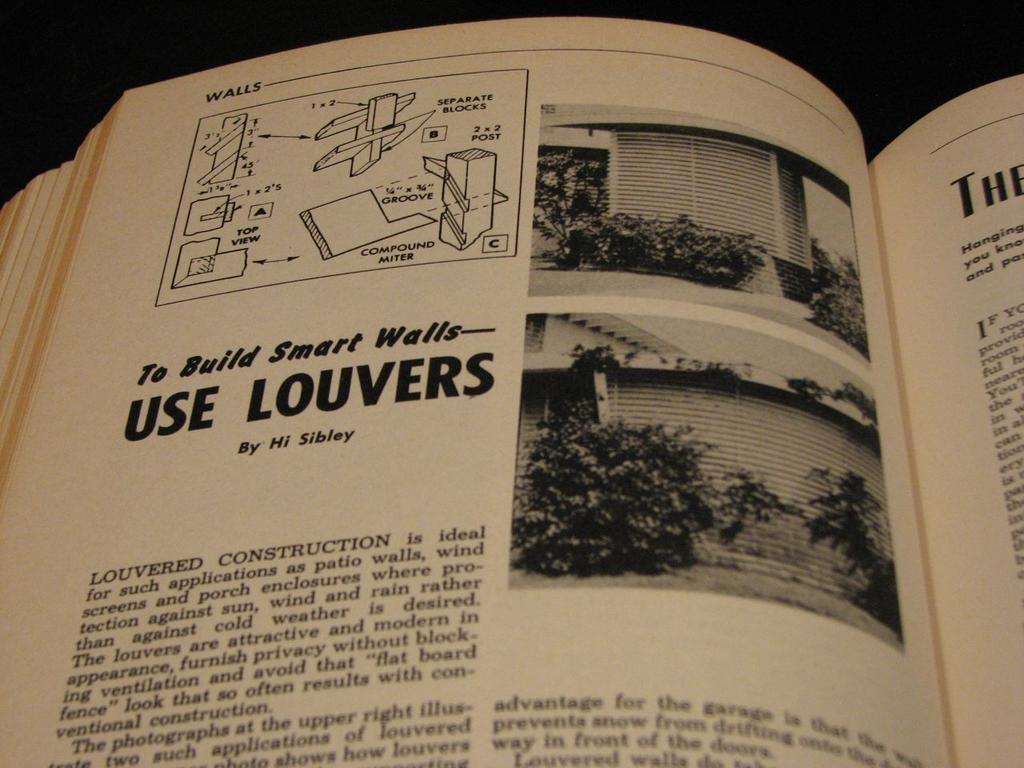<image>
Write a terse but informative summary of the picture. Book about bilding smart walls and use louvers by Hi Sibley 